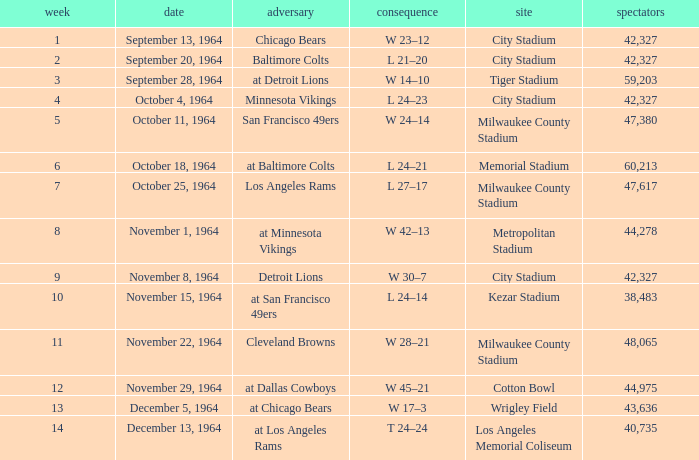What venue held that game with a result of l 24–14? Kezar Stadium. 